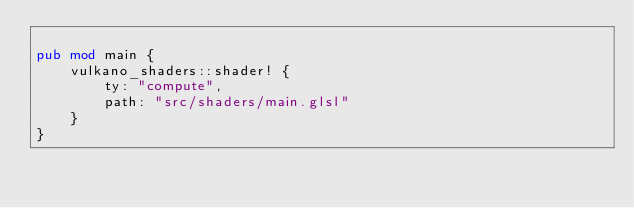<code> <loc_0><loc_0><loc_500><loc_500><_Rust_>
pub mod main {
	vulkano_shaders::shader! {
		ty: "compute",
		path: "src/shaders/main.glsl"
	}
}
</code> 